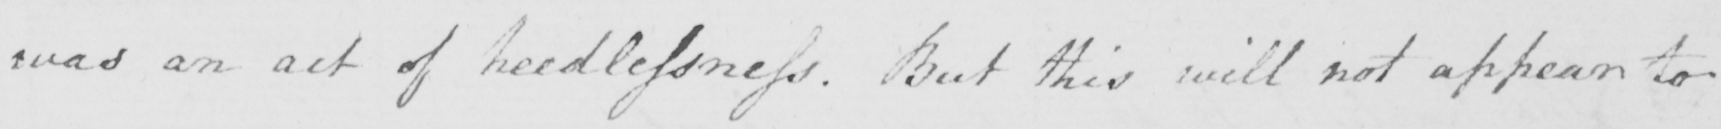Transcribe the text shown in this historical manuscript line. was an act of heedlessness . But this will not appear to 